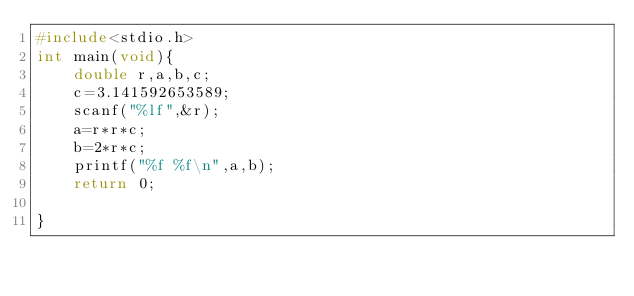<code> <loc_0><loc_0><loc_500><loc_500><_C_>#include<stdio.h>
int main(void){
    double r,a,b,c;
    c=3.141592653589;
    scanf("%lf",&r);
    a=r*r*c;
    b=2*r*c;
    printf("%f %f\n",a,b);
    return 0;

}</code> 